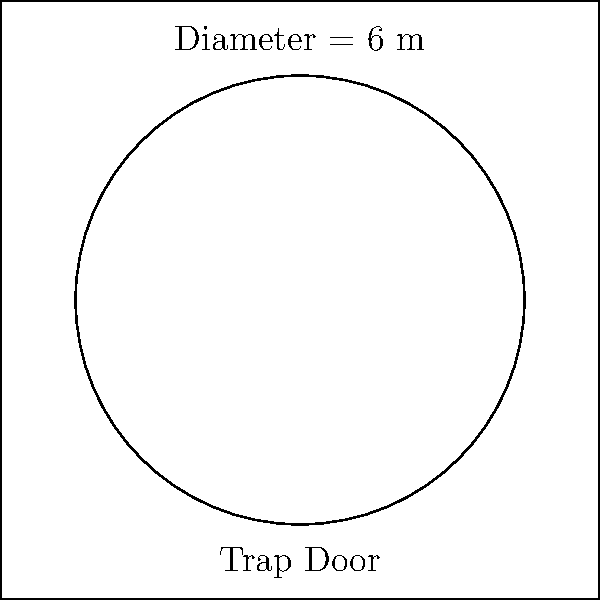In your latest thriller, the protagonist discovers a circular trap door in the antagonist's secret lair. The trap door has a diameter of 6 meters. What is the perimeter of this trap door, rounded to the nearest centimeter? To find the perimeter of the circular trap door, we need to calculate its circumference. Let's break it down step-by-step:

1. We know the diameter is 6 meters. The radius is half of the diameter:
   $r = \frac{6}{2} = 3$ meters

2. The formula for the circumference of a circle is:
   $C = 2\pi r$

3. Substituting our radius value:
   $C = 2\pi(3)$

4. Simplify:
   $C = 6\pi$ meters

5. To calculate the exact value, multiply by π:
   $C = 6 \times 3.14159...$ meters

6. This gives us approximately 18.84955592 meters

7. Rounding to the nearest centimeter (0.01 meter):
   18.85 meters

Therefore, the perimeter of the trap door is 18.85 meters or 1885 centimeters.
Answer: 18.85 m 